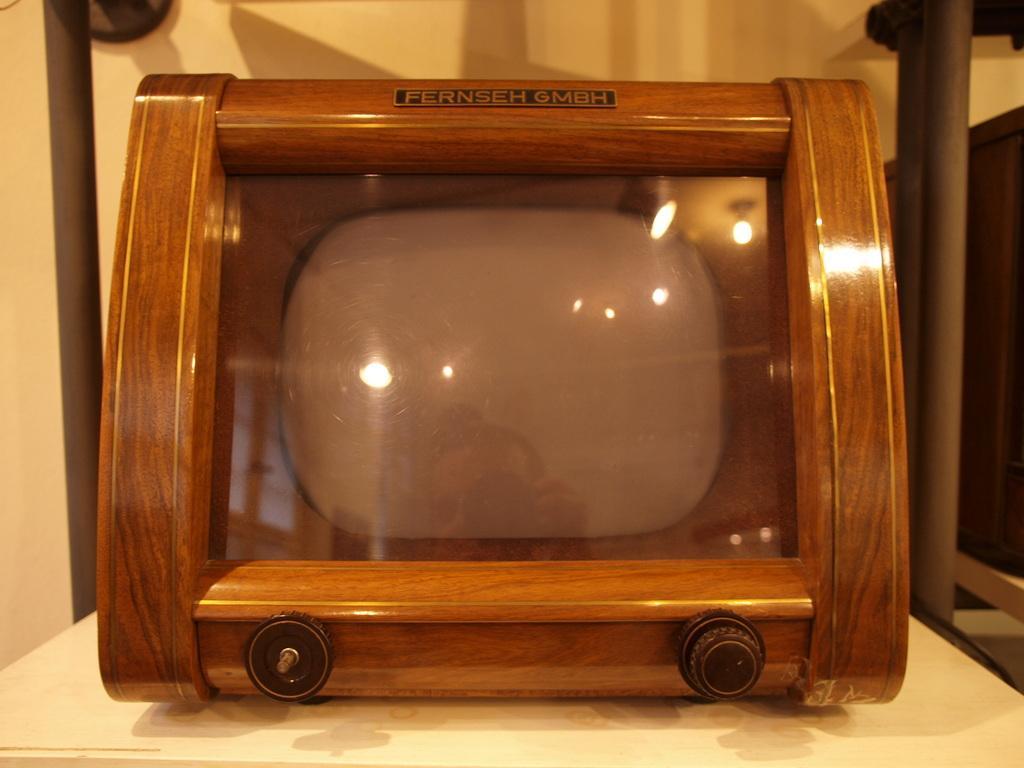Could you give a brief overview of what you see in this image? In this image we can see an object placed on the table. In the background there is a wall and we can see a stand. 